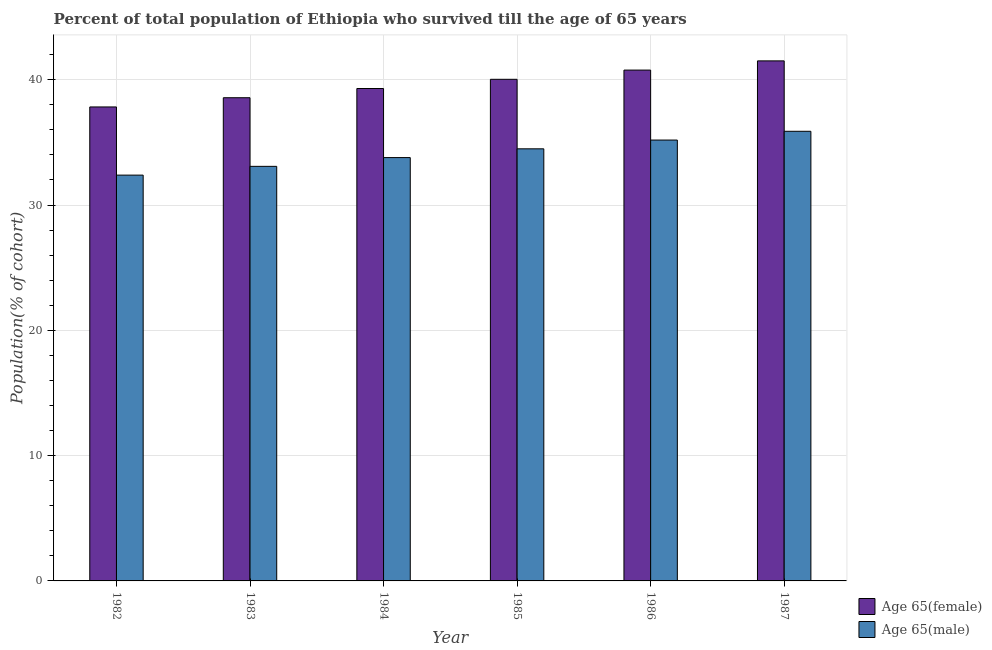Are the number of bars per tick equal to the number of legend labels?
Your answer should be very brief. Yes. Are the number of bars on each tick of the X-axis equal?
Provide a short and direct response. Yes. How many bars are there on the 4th tick from the left?
Your response must be concise. 2. In how many cases, is the number of bars for a given year not equal to the number of legend labels?
Make the answer very short. 0. What is the percentage of female population who survived till age of 65 in 1983?
Your answer should be compact. 38.56. Across all years, what is the maximum percentage of male population who survived till age of 65?
Offer a terse response. 35.89. Across all years, what is the minimum percentage of male population who survived till age of 65?
Provide a succinct answer. 32.39. In which year was the percentage of female population who survived till age of 65 minimum?
Your response must be concise. 1982. What is the total percentage of female population who survived till age of 65 in the graph?
Keep it short and to the point. 238. What is the difference between the percentage of male population who survived till age of 65 in 1985 and that in 1987?
Your answer should be very brief. -1.4. What is the difference between the percentage of male population who survived till age of 65 in 1984 and the percentage of female population who survived till age of 65 in 1982?
Your answer should be very brief. 1.4. What is the average percentage of female population who survived till age of 65 per year?
Keep it short and to the point. 39.67. In the year 1987, what is the difference between the percentage of male population who survived till age of 65 and percentage of female population who survived till age of 65?
Make the answer very short. 0. In how many years, is the percentage of female population who survived till age of 65 greater than 24 %?
Give a very brief answer. 6. What is the ratio of the percentage of female population who survived till age of 65 in 1982 to that in 1984?
Provide a succinct answer. 0.96. Is the percentage of male population who survived till age of 65 in 1985 less than that in 1986?
Keep it short and to the point. Yes. What is the difference between the highest and the second highest percentage of female population who survived till age of 65?
Your answer should be compact. 0.74. What is the difference between the highest and the lowest percentage of female population who survived till age of 65?
Provide a short and direct response. 3.68. In how many years, is the percentage of male population who survived till age of 65 greater than the average percentage of male population who survived till age of 65 taken over all years?
Your answer should be compact. 3. What does the 2nd bar from the left in 1985 represents?
Provide a short and direct response. Age 65(male). What does the 2nd bar from the right in 1985 represents?
Your answer should be very brief. Age 65(female). How many bars are there?
Give a very brief answer. 12. What is the difference between two consecutive major ticks on the Y-axis?
Offer a terse response. 10. Are the values on the major ticks of Y-axis written in scientific E-notation?
Your answer should be compact. No. How are the legend labels stacked?
Ensure brevity in your answer.  Vertical. What is the title of the graph?
Offer a very short reply. Percent of total population of Ethiopia who survived till the age of 65 years. Does "External balance on goods" appear as one of the legend labels in the graph?
Offer a very short reply. No. What is the label or title of the Y-axis?
Your answer should be compact. Population(% of cohort). What is the Population(% of cohort) of Age 65(female) in 1982?
Your answer should be compact. 37.83. What is the Population(% of cohort) of Age 65(male) in 1982?
Give a very brief answer. 32.39. What is the Population(% of cohort) in Age 65(female) in 1983?
Make the answer very short. 38.56. What is the Population(% of cohort) of Age 65(male) in 1983?
Keep it short and to the point. 33.09. What is the Population(% of cohort) in Age 65(female) in 1984?
Offer a terse response. 39.3. What is the Population(% of cohort) of Age 65(male) in 1984?
Your response must be concise. 33.79. What is the Population(% of cohort) in Age 65(female) in 1985?
Provide a succinct answer. 40.03. What is the Population(% of cohort) of Age 65(male) in 1985?
Give a very brief answer. 34.49. What is the Population(% of cohort) in Age 65(female) in 1986?
Your answer should be compact. 40.77. What is the Population(% of cohort) in Age 65(male) in 1986?
Offer a terse response. 35.19. What is the Population(% of cohort) of Age 65(female) in 1987?
Provide a succinct answer. 41.51. What is the Population(% of cohort) in Age 65(male) in 1987?
Ensure brevity in your answer.  35.89. Across all years, what is the maximum Population(% of cohort) of Age 65(female)?
Offer a terse response. 41.51. Across all years, what is the maximum Population(% of cohort) of Age 65(male)?
Offer a terse response. 35.89. Across all years, what is the minimum Population(% of cohort) in Age 65(female)?
Provide a succinct answer. 37.83. Across all years, what is the minimum Population(% of cohort) in Age 65(male)?
Your answer should be very brief. 32.39. What is the total Population(% of cohort) in Age 65(female) in the graph?
Your response must be concise. 238. What is the total Population(% of cohort) of Age 65(male) in the graph?
Your answer should be very brief. 204.82. What is the difference between the Population(% of cohort) of Age 65(female) in 1982 and that in 1983?
Provide a succinct answer. -0.74. What is the difference between the Population(% of cohort) of Age 65(male) in 1982 and that in 1983?
Make the answer very short. -0.7. What is the difference between the Population(% of cohort) in Age 65(female) in 1982 and that in 1984?
Provide a short and direct response. -1.47. What is the difference between the Population(% of cohort) in Age 65(male) in 1982 and that in 1984?
Your answer should be compact. -1.4. What is the difference between the Population(% of cohort) of Age 65(female) in 1982 and that in 1985?
Offer a terse response. -2.21. What is the difference between the Population(% of cohort) of Age 65(male) in 1982 and that in 1985?
Offer a very short reply. -2.1. What is the difference between the Population(% of cohort) in Age 65(female) in 1982 and that in 1986?
Give a very brief answer. -2.94. What is the difference between the Population(% of cohort) of Age 65(male) in 1982 and that in 1986?
Your answer should be compact. -2.8. What is the difference between the Population(% of cohort) in Age 65(female) in 1982 and that in 1987?
Your answer should be compact. -3.68. What is the difference between the Population(% of cohort) in Age 65(male) in 1982 and that in 1987?
Provide a short and direct response. -3.5. What is the difference between the Population(% of cohort) in Age 65(female) in 1983 and that in 1984?
Offer a very short reply. -0.74. What is the difference between the Population(% of cohort) in Age 65(male) in 1983 and that in 1984?
Keep it short and to the point. -0.7. What is the difference between the Population(% of cohort) in Age 65(female) in 1983 and that in 1985?
Keep it short and to the point. -1.47. What is the difference between the Population(% of cohort) in Age 65(male) in 1983 and that in 1985?
Ensure brevity in your answer.  -1.4. What is the difference between the Population(% of cohort) in Age 65(female) in 1983 and that in 1986?
Provide a short and direct response. -2.21. What is the difference between the Population(% of cohort) of Age 65(male) in 1983 and that in 1986?
Provide a succinct answer. -2.1. What is the difference between the Population(% of cohort) of Age 65(female) in 1983 and that in 1987?
Provide a succinct answer. -2.94. What is the difference between the Population(% of cohort) in Age 65(male) in 1983 and that in 1987?
Ensure brevity in your answer.  -2.8. What is the difference between the Population(% of cohort) in Age 65(female) in 1984 and that in 1985?
Make the answer very short. -0.74. What is the difference between the Population(% of cohort) of Age 65(male) in 1984 and that in 1985?
Provide a succinct answer. -0.7. What is the difference between the Population(% of cohort) in Age 65(female) in 1984 and that in 1986?
Keep it short and to the point. -1.47. What is the difference between the Population(% of cohort) of Age 65(male) in 1984 and that in 1986?
Provide a short and direct response. -1.4. What is the difference between the Population(% of cohort) in Age 65(female) in 1984 and that in 1987?
Keep it short and to the point. -2.21. What is the difference between the Population(% of cohort) of Age 65(male) in 1984 and that in 1987?
Provide a succinct answer. -2.1. What is the difference between the Population(% of cohort) of Age 65(female) in 1985 and that in 1986?
Provide a short and direct response. -0.74. What is the difference between the Population(% of cohort) of Age 65(male) in 1985 and that in 1986?
Keep it short and to the point. -0.7. What is the difference between the Population(% of cohort) in Age 65(female) in 1985 and that in 1987?
Offer a terse response. -1.47. What is the difference between the Population(% of cohort) of Age 65(male) in 1985 and that in 1987?
Keep it short and to the point. -1.4. What is the difference between the Population(% of cohort) in Age 65(female) in 1986 and that in 1987?
Offer a terse response. -0.74. What is the difference between the Population(% of cohort) in Age 65(male) in 1986 and that in 1987?
Provide a short and direct response. -0.7. What is the difference between the Population(% of cohort) of Age 65(female) in 1982 and the Population(% of cohort) of Age 65(male) in 1983?
Make the answer very short. 4.74. What is the difference between the Population(% of cohort) in Age 65(female) in 1982 and the Population(% of cohort) in Age 65(male) in 1984?
Provide a short and direct response. 4.04. What is the difference between the Population(% of cohort) in Age 65(female) in 1982 and the Population(% of cohort) in Age 65(male) in 1985?
Ensure brevity in your answer.  3.34. What is the difference between the Population(% of cohort) of Age 65(female) in 1982 and the Population(% of cohort) of Age 65(male) in 1986?
Provide a succinct answer. 2.64. What is the difference between the Population(% of cohort) in Age 65(female) in 1982 and the Population(% of cohort) in Age 65(male) in 1987?
Provide a succinct answer. 1.94. What is the difference between the Population(% of cohort) of Age 65(female) in 1983 and the Population(% of cohort) of Age 65(male) in 1984?
Provide a short and direct response. 4.78. What is the difference between the Population(% of cohort) of Age 65(female) in 1983 and the Population(% of cohort) of Age 65(male) in 1985?
Your answer should be compact. 4.08. What is the difference between the Population(% of cohort) of Age 65(female) in 1983 and the Population(% of cohort) of Age 65(male) in 1986?
Provide a short and direct response. 3.38. What is the difference between the Population(% of cohort) of Age 65(female) in 1983 and the Population(% of cohort) of Age 65(male) in 1987?
Keep it short and to the point. 2.68. What is the difference between the Population(% of cohort) in Age 65(female) in 1984 and the Population(% of cohort) in Age 65(male) in 1985?
Provide a succinct answer. 4.81. What is the difference between the Population(% of cohort) of Age 65(female) in 1984 and the Population(% of cohort) of Age 65(male) in 1986?
Make the answer very short. 4.11. What is the difference between the Population(% of cohort) in Age 65(female) in 1984 and the Population(% of cohort) in Age 65(male) in 1987?
Ensure brevity in your answer.  3.41. What is the difference between the Population(% of cohort) of Age 65(female) in 1985 and the Population(% of cohort) of Age 65(male) in 1986?
Give a very brief answer. 4.85. What is the difference between the Population(% of cohort) in Age 65(female) in 1985 and the Population(% of cohort) in Age 65(male) in 1987?
Provide a short and direct response. 4.15. What is the difference between the Population(% of cohort) in Age 65(female) in 1986 and the Population(% of cohort) in Age 65(male) in 1987?
Keep it short and to the point. 4.88. What is the average Population(% of cohort) in Age 65(female) per year?
Offer a terse response. 39.67. What is the average Population(% of cohort) in Age 65(male) per year?
Your answer should be very brief. 34.14. In the year 1982, what is the difference between the Population(% of cohort) of Age 65(female) and Population(% of cohort) of Age 65(male)?
Keep it short and to the point. 5.44. In the year 1983, what is the difference between the Population(% of cohort) of Age 65(female) and Population(% of cohort) of Age 65(male)?
Provide a short and direct response. 5.48. In the year 1984, what is the difference between the Population(% of cohort) in Age 65(female) and Population(% of cohort) in Age 65(male)?
Your answer should be compact. 5.51. In the year 1985, what is the difference between the Population(% of cohort) of Age 65(female) and Population(% of cohort) of Age 65(male)?
Your answer should be very brief. 5.55. In the year 1986, what is the difference between the Population(% of cohort) of Age 65(female) and Population(% of cohort) of Age 65(male)?
Offer a very short reply. 5.58. In the year 1987, what is the difference between the Population(% of cohort) of Age 65(female) and Population(% of cohort) of Age 65(male)?
Offer a very short reply. 5.62. What is the ratio of the Population(% of cohort) in Age 65(female) in 1982 to that in 1983?
Keep it short and to the point. 0.98. What is the ratio of the Population(% of cohort) of Age 65(male) in 1982 to that in 1983?
Ensure brevity in your answer.  0.98. What is the ratio of the Population(% of cohort) in Age 65(female) in 1982 to that in 1984?
Keep it short and to the point. 0.96. What is the ratio of the Population(% of cohort) of Age 65(male) in 1982 to that in 1984?
Make the answer very short. 0.96. What is the ratio of the Population(% of cohort) in Age 65(female) in 1982 to that in 1985?
Your answer should be compact. 0.94. What is the ratio of the Population(% of cohort) of Age 65(male) in 1982 to that in 1985?
Offer a terse response. 0.94. What is the ratio of the Population(% of cohort) of Age 65(female) in 1982 to that in 1986?
Offer a very short reply. 0.93. What is the ratio of the Population(% of cohort) in Age 65(male) in 1982 to that in 1986?
Keep it short and to the point. 0.92. What is the ratio of the Population(% of cohort) in Age 65(female) in 1982 to that in 1987?
Keep it short and to the point. 0.91. What is the ratio of the Population(% of cohort) in Age 65(male) in 1982 to that in 1987?
Keep it short and to the point. 0.9. What is the ratio of the Population(% of cohort) of Age 65(female) in 1983 to that in 1984?
Provide a short and direct response. 0.98. What is the ratio of the Population(% of cohort) of Age 65(male) in 1983 to that in 1984?
Give a very brief answer. 0.98. What is the ratio of the Population(% of cohort) of Age 65(female) in 1983 to that in 1985?
Your response must be concise. 0.96. What is the ratio of the Population(% of cohort) in Age 65(male) in 1983 to that in 1985?
Make the answer very short. 0.96. What is the ratio of the Population(% of cohort) in Age 65(female) in 1983 to that in 1986?
Your answer should be very brief. 0.95. What is the ratio of the Population(% of cohort) in Age 65(male) in 1983 to that in 1986?
Keep it short and to the point. 0.94. What is the ratio of the Population(% of cohort) of Age 65(female) in 1983 to that in 1987?
Your answer should be compact. 0.93. What is the ratio of the Population(% of cohort) in Age 65(male) in 1983 to that in 1987?
Keep it short and to the point. 0.92. What is the ratio of the Population(% of cohort) of Age 65(female) in 1984 to that in 1985?
Your response must be concise. 0.98. What is the ratio of the Population(% of cohort) in Age 65(male) in 1984 to that in 1985?
Make the answer very short. 0.98. What is the ratio of the Population(% of cohort) of Age 65(female) in 1984 to that in 1986?
Provide a succinct answer. 0.96. What is the ratio of the Population(% of cohort) in Age 65(male) in 1984 to that in 1986?
Your answer should be very brief. 0.96. What is the ratio of the Population(% of cohort) in Age 65(female) in 1984 to that in 1987?
Offer a terse response. 0.95. What is the ratio of the Population(% of cohort) in Age 65(male) in 1984 to that in 1987?
Provide a succinct answer. 0.94. What is the ratio of the Population(% of cohort) of Age 65(male) in 1985 to that in 1986?
Your response must be concise. 0.98. What is the ratio of the Population(% of cohort) of Age 65(female) in 1985 to that in 1987?
Ensure brevity in your answer.  0.96. What is the ratio of the Population(% of cohort) in Age 65(male) in 1985 to that in 1987?
Your answer should be compact. 0.96. What is the ratio of the Population(% of cohort) in Age 65(female) in 1986 to that in 1987?
Your response must be concise. 0.98. What is the ratio of the Population(% of cohort) of Age 65(male) in 1986 to that in 1987?
Your answer should be very brief. 0.98. What is the difference between the highest and the second highest Population(% of cohort) in Age 65(female)?
Keep it short and to the point. 0.74. What is the difference between the highest and the second highest Population(% of cohort) in Age 65(male)?
Your answer should be very brief. 0.7. What is the difference between the highest and the lowest Population(% of cohort) of Age 65(female)?
Your answer should be compact. 3.68. What is the difference between the highest and the lowest Population(% of cohort) in Age 65(male)?
Offer a very short reply. 3.5. 